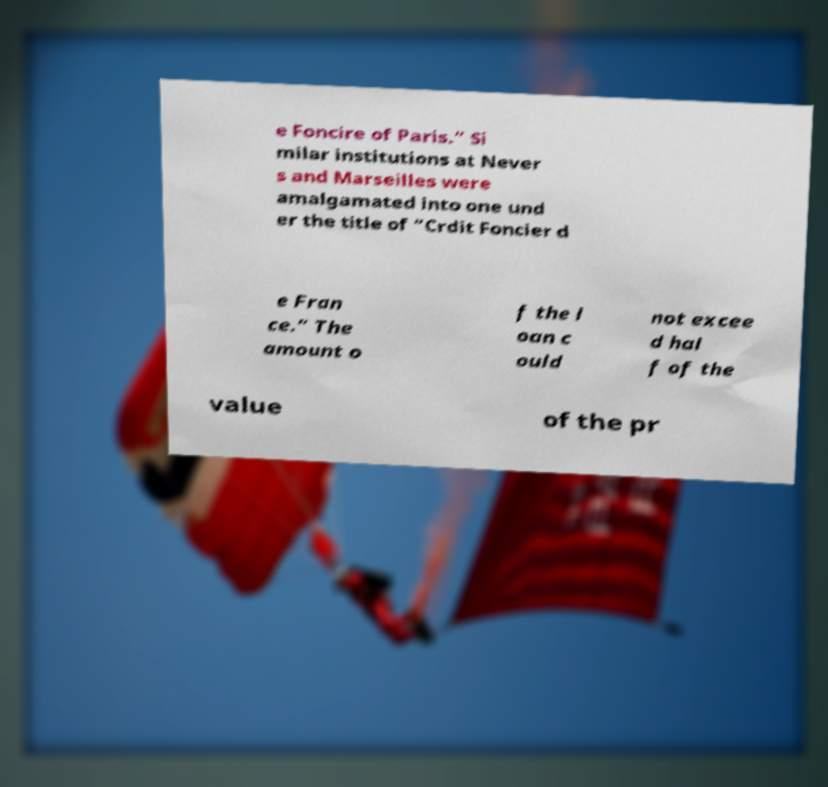Can you accurately transcribe the text from the provided image for me? e Foncire of Paris.” Si milar institutions at Never s and Marseilles were amalgamated into one und er the title of “Crdit Foncier d e Fran ce.” The amount o f the l oan c ould not excee d hal f of the value of the pr 